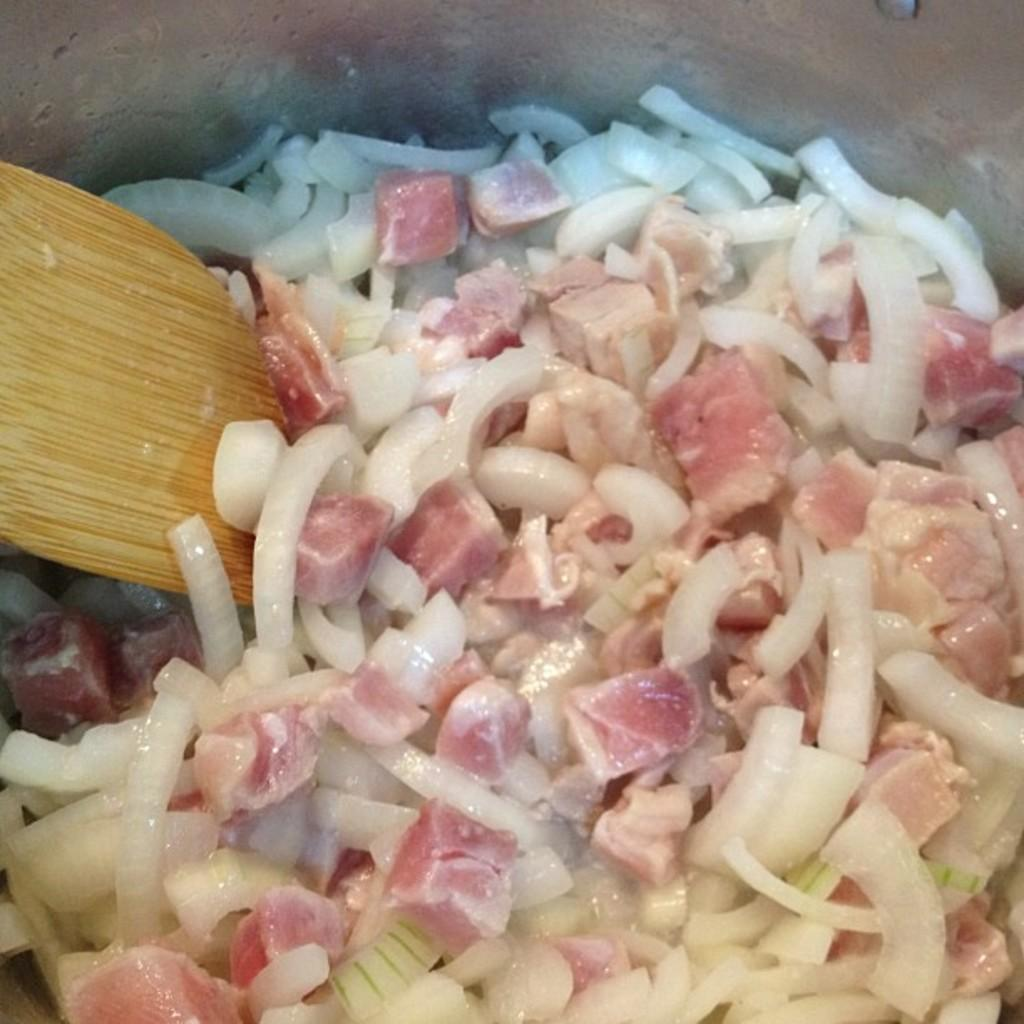What type of vegetable is visible in the image? There is a chopped onion in the image. What type of food is also present in the image? There is meat in the image. What utensil can be seen in the image? There is a spoon in the image. What type of harmony can be heard in the background of the image? There is no audible harmony present in the image, as it is a still image featuring chopped onion, meat, and a spoon. 